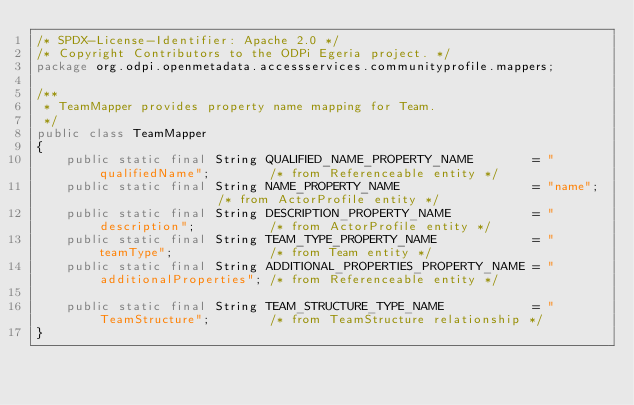<code> <loc_0><loc_0><loc_500><loc_500><_Java_>/* SPDX-License-Identifier: Apache 2.0 */
/* Copyright Contributors to the ODPi Egeria project. */
package org.odpi.openmetadata.accessservices.communityprofile.mappers;

/**
 * TeamMapper provides property name mapping for Team.
 */
public class TeamMapper
{
    public static final String QUALIFIED_NAME_PROPERTY_NAME        = "qualifiedName";        /* from Referenceable entity */
    public static final String NAME_PROPERTY_NAME                  = "name";                 /* from ActorProfile entity */
    public static final String DESCRIPTION_PROPERTY_NAME           = "description";          /* from ActorProfile entity */
    public static final String TEAM_TYPE_PROPERTY_NAME             = "teamType";             /* from Team entity */
    public static final String ADDITIONAL_PROPERTIES_PROPERTY_NAME = "additionalProperties"; /* from Referenceable entity */

    public static final String TEAM_STRUCTURE_TYPE_NAME            = "TeamStructure";        /* from TeamStructure relationship */
}
</code> 